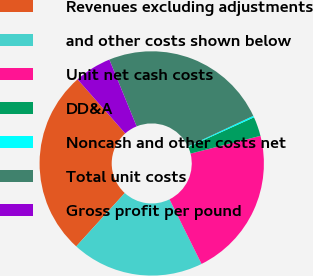<chart> <loc_0><loc_0><loc_500><loc_500><pie_chart><fcel>Revenues excluding adjustments<fcel>and other costs shown below<fcel>Unit net cash costs<fcel>DD&A<fcel>Noncash and other costs net<fcel>Total unit costs<fcel>Gross profit per pound<nl><fcel>26.74%<fcel>19.08%<fcel>21.63%<fcel>2.79%<fcel>0.23%<fcel>24.19%<fcel>5.34%<nl></chart> 